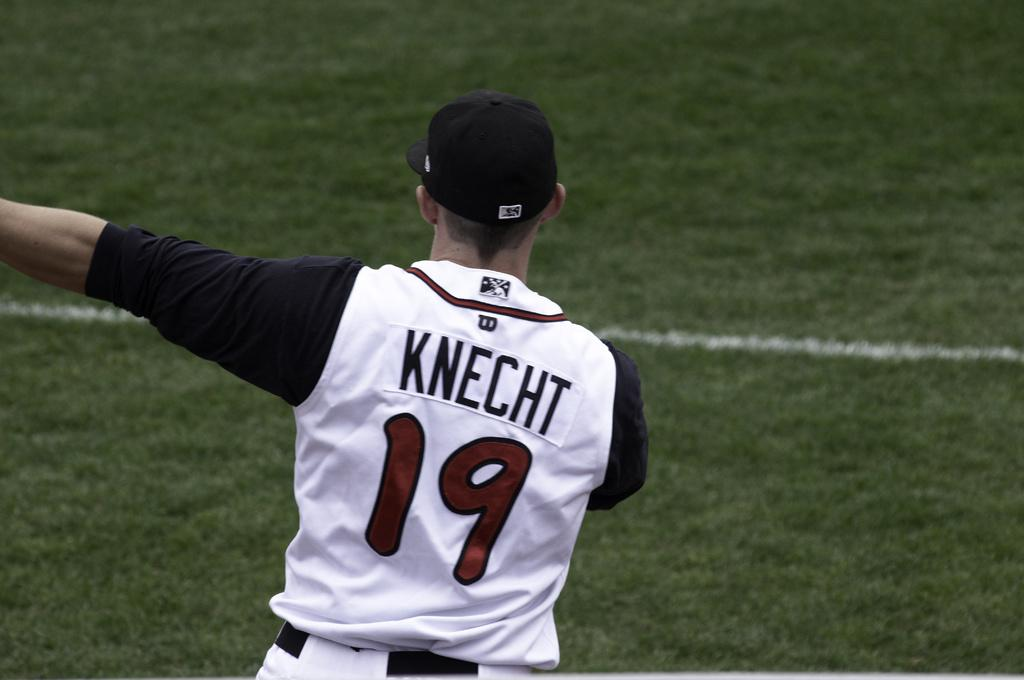<image>
Summarize the visual content of the image. A baseball player, named Knecht, wears jersey number 19. 